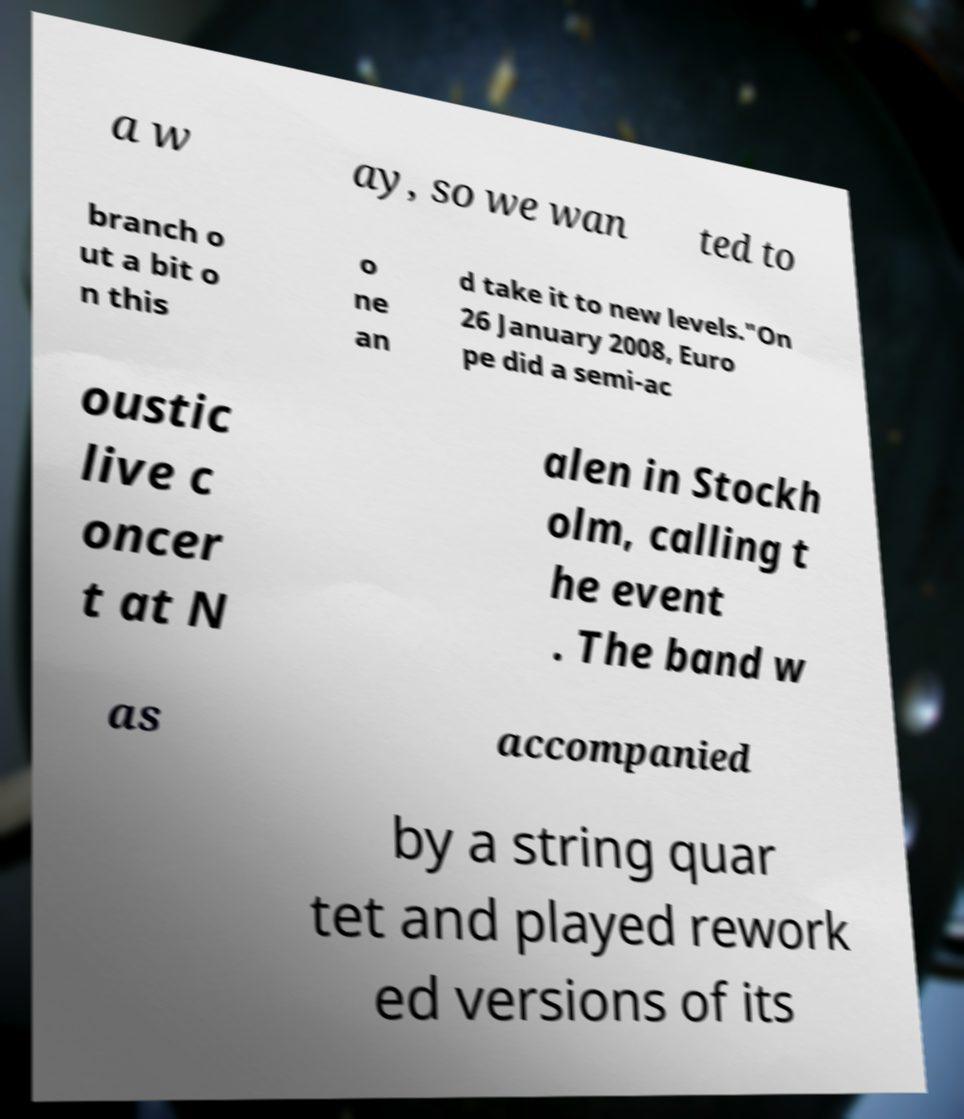Can you read and provide the text displayed in the image?This photo seems to have some interesting text. Can you extract and type it out for me? a w ay, so we wan ted to branch o ut a bit o n this o ne an d take it to new levels."On 26 January 2008, Euro pe did a semi-ac oustic live c oncer t at N alen in Stockh olm, calling t he event . The band w as accompanied by a string quar tet and played rework ed versions of its 